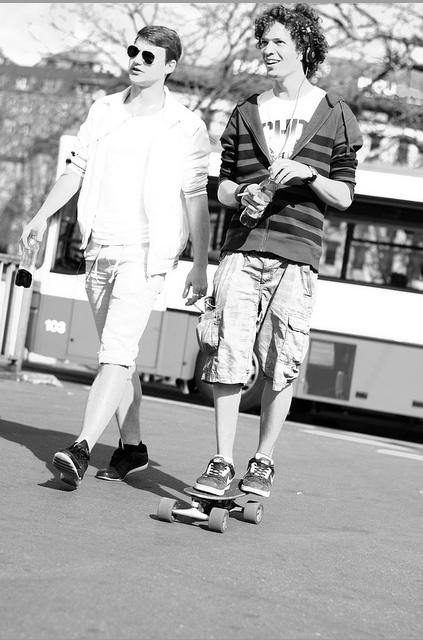What is the person on the left doing?

Choices:
A) studying
B) eating
C) walking
D) writing walking 